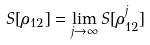<formula> <loc_0><loc_0><loc_500><loc_500>S [ \rho _ { 1 2 } ] = \lim _ { j \to \infty } S [ \rho _ { 1 2 } ^ { j } ]</formula> 